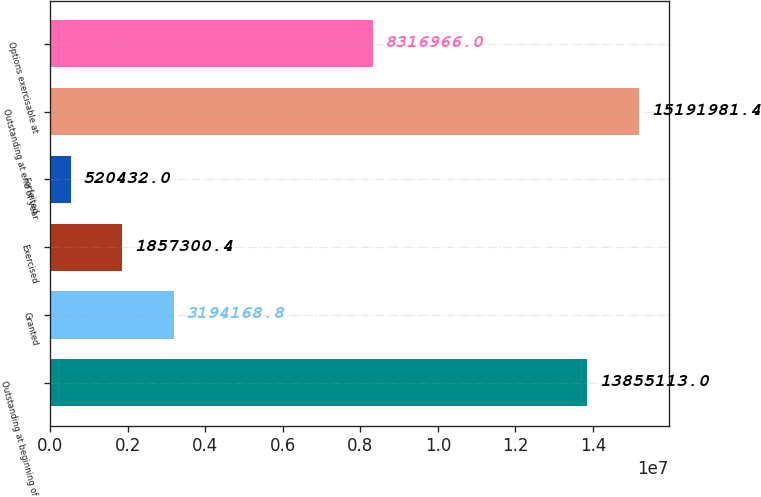<chart> <loc_0><loc_0><loc_500><loc_500><bar_chart><fcel>Outstanding at beginning of<fcel>Granted<fcel>Exercised<fcel>Forfeited<fcel>Outstanding at end of year<fcel>Options exercisable at<nl><fcel>1.38551e+07<fcel>3.19417e+06<fcel>1.8573e+06<fcel>520432<fcel>1.5192e+07<fcel>8.31697e+06<nl></chart> 